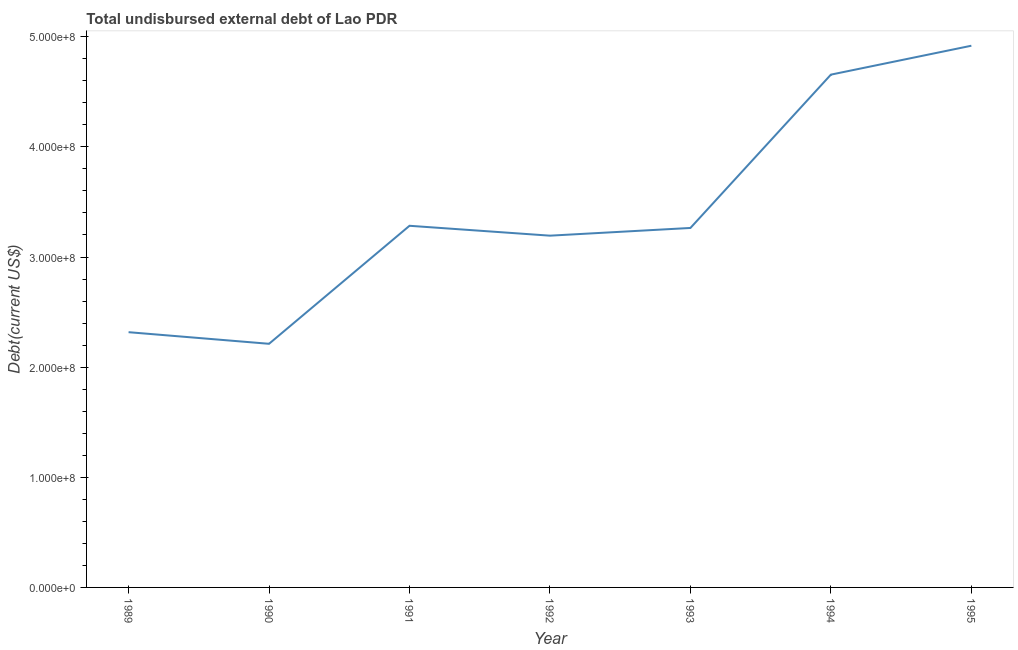What is the total debt in 1993?
Keep it short and to the point. 3.26e+08. Across all years, what is the maximum total debt?
Provide a succinct answer. 4.92e+08. Across all years, what is the minimum total debt?
Your answer should be compact. 2.21e+08. In which year was the total debt maximum?
Keep it short and to the point. 1995. In which year was the total debt minimum?
Offer a very short reply. 1990. What is the sum of the total debt?
Your response must be concise. 2.38e+09. What is the difference between the total debt in 1989 and 1990?
Your answer should be compact. 1.05e+07. What is the average total debt per year?
Provide a short and direct response. 3.41e+08. What is the median total debt?
Provide a short and direct response. 3.26e+08. In how many years, is the total debt greater than 440000000 US$?
Give a very brief answer. 2. Do a majority of the years between 1994 and 1992 (inclusive) have total debt greater than 80000000 US$?
Your answer should be very brief. No. What is the ratio of the total debt in 1992 to that in 1994?
Make the answer very short. 0.69. Is the difference between the total debt in 1989 and 1992 greater than the difference between any two years?
Provide a succinct answer. No. What is the difference between the highest and the second highest total debt?
Your answer should be very brief. 2.62e+07. What is the difference between the highest and the lowest total debt?
Offer a very short reply. 2.71e+08. Does the total debt monotonically increase over the years?
Give a very brief answer. No. How many lines are there?
Keep it short and to the point. 1. What is the difference between two consecutive major ticks on the Y-axis?
Your response must be concise. 1.00e+08. What is the title of the graph?
Provide a succinct answer. Total undisbursed external debt of Lao PDR. What is the label or title of the Y-axis?
Ensure brevity in your answer.  Debt(current US$). What is the Debt(current US$) of 1989?
Offer a very short reply. 2.32e+08. What is the Debt(current US$) of 1990?
Keep it short and to the point. 2.21e+08. What is the Debt(current US$) of 1991?
Ensure brevity in your answer.  3.28e+08. What is the Debt(current US$) in 1992?
Provide a succinct answer. 3.19e+08. What is the Debt(current US$) in 1993?
Give a very brief answer. 3.26e+08. What is the Debt(current US$) in 1994?
Ensure brevity in your answer.  4.66e+08. What is the Debt(current US$) of 1995?
Give a very brief answer. 4.92e+08. What is the difference between the Debt(current US$) in 1989 and 1990?
Keep it short and to the point. 1.05e+07. What is the difference between the Debt(current US$) in 1989 and 1991?
Your response must be concise. -9.66e+07. What is the difference between the Debt(current US$) in 1989 and 1992?
Offer a very short reply. -8.76e+07. What is the difference between the Debt(current US$) in 1989 and 1993?
Your response must be concise. -9.46e+07. What is the difference between the Debt(current US$) in 1989 and 1994?
Your answer should be compact. -2.34e+08. What is the difference between the Debt(current US$) in 1989 and 1995?
Your answer should be compact. -2.60e+08. What is the difference between the Debt(current US$) in 1990 and 1991?
Your answer should be compact. -1.07e+08. What is the difference between the Debt(current US$) in 1990 and 1992?
Provide a short and direct response. -9.82e+07. What is the difference between the Debt(current US$) in 1990 and 1993?
Provide a succinct answer. -1.05e+08. What is the difference between the Debt(current US$) in 1990 and 1994?
Offer a terse response. -2.44e+08. What is the difference between the Debt(current US$) in 1990 and 1995?
Offer a terse response. -2.71e+08. What is the difference between the Debt(current US$) in 1991 and 1992?
Offer a very short reply. 8.98e+06. What is the difference between the Debt(current US$) in 1991 and 1993?
Offer a terse response. 1.97e+06. What is the difference between the Debt(current US$) in 1991 and 1994?
Your response must be concise. -1.37e+08. What is the difference between the Debt(current US$) in 1991 and 1995?
Make the answer very short. -1.63e+08. What is the difference between the Debt(current US$) in 1992 and 1993?
Make the answer very short. -7.00e+06. What is the difference between the Debt(current US$) in 1992 and 1994?
Provide a short and direct response. -1.46e+08. What is the difference between the Debt(current US$) in 1992 and 1995?
Give a very brief answer. -1.72e+08. What is the difference between the Debt(current US$) in 1993 and 1994?
Your answer should be compact. -1.39e+08. What is the difference between the Debt(current US$) in 1993 and 1995?
Ensure brevity in your answer.  -1.65e+08. What is the difference between the Debt(current US$) in 1994 and 1995?
Keep it short and to the point. -2.62e+07. What is the ratio of the Debt(current US$) in 1989 to that in 1990?
Ensure brevity in your answer.  1.05. What is the ratio of the Debt(current US$) in 1989 to that in 1991?
Ensure brevity in your answer.  0.71. What is the ratio of the Debt(current US$) in 1989 to that in 1992?
Your response must be concise. 0.73. What is the ratio of the Debt(current US$) in 1989 to that in 1993?
Provide a short and direct response. 0.71. What is the ratio of the Debt(current US$) in 1989 to that in 1994?
Your answer should be compact. 0.5. What is the ratio of the Debt(current US$) in 1989 to that in 1995?
Your answer should be compact. 0.47. What is the ratio of the Debt(current US$) in 1990 to that in 1991?
Keep it short and to the point. 0.67. What is the ratio of the Debt(current US$) in 1990 to that in 1992?
Your answer should be very brief. 0.69. What is the ratio of the Debt(current US$) in 1990 to that in 1993?
Your answer should be very brief. 0.68. What is the ratio of the Debt(current US$) in 1990 to that in 1994?
Your answer should be compact. 0.47. What is the ratio of the Debt(current US$) in 1990 to that in 1995?
Ensure brevity in your answer.  0.45. What is the ratio of the Debt(current US$) in 1991 to that in 1992?
Provide a succinct answer. 1.03. What is the ratio of the Debt(current US$) in 1991 to that in 1993?
Your response must be concise. 1.01. What is the ratio of the Debt(current US$) in 1991 to that in 1994?
Keep it short and to the point. 0.7. What is the ratio of the Debt(current US$) in 1991 to that in 1995?
Provide a short and direct response. 0.67. What is the ratio of the Debt(current US$) in 1992 to that in 1993?
Offer a terse response. 0.98. What is the ratio of the Debt(current US$) in 1992 to that in 1994?
Provide a short and direct response. 0.69. What is the ratio of the Debt(current US$) in 1992 to that in 1995?
Your response must be concise. 0.65. What is the ratio of the Debt(current US$) in 1993 to that in 1994?
Give a very brief answer. 0.7. What is the ratio of the Debt(current US$) in 1993 to that in 1995?
Your answer should be compact. 0.66. What is the ratio of the Debt(current US$) in 1994 to that in 1995?
Your answer should be very brief. 0.95. 